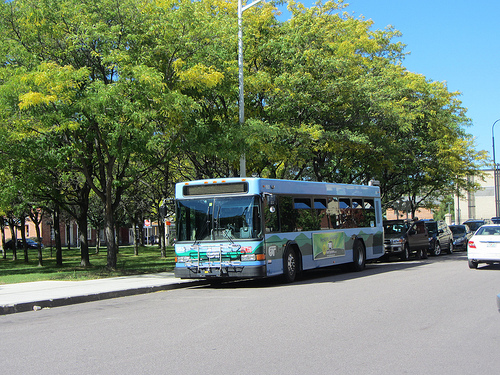Does the sidewalk look white? Yes, the sidewalk appears to be white or light-colored. 